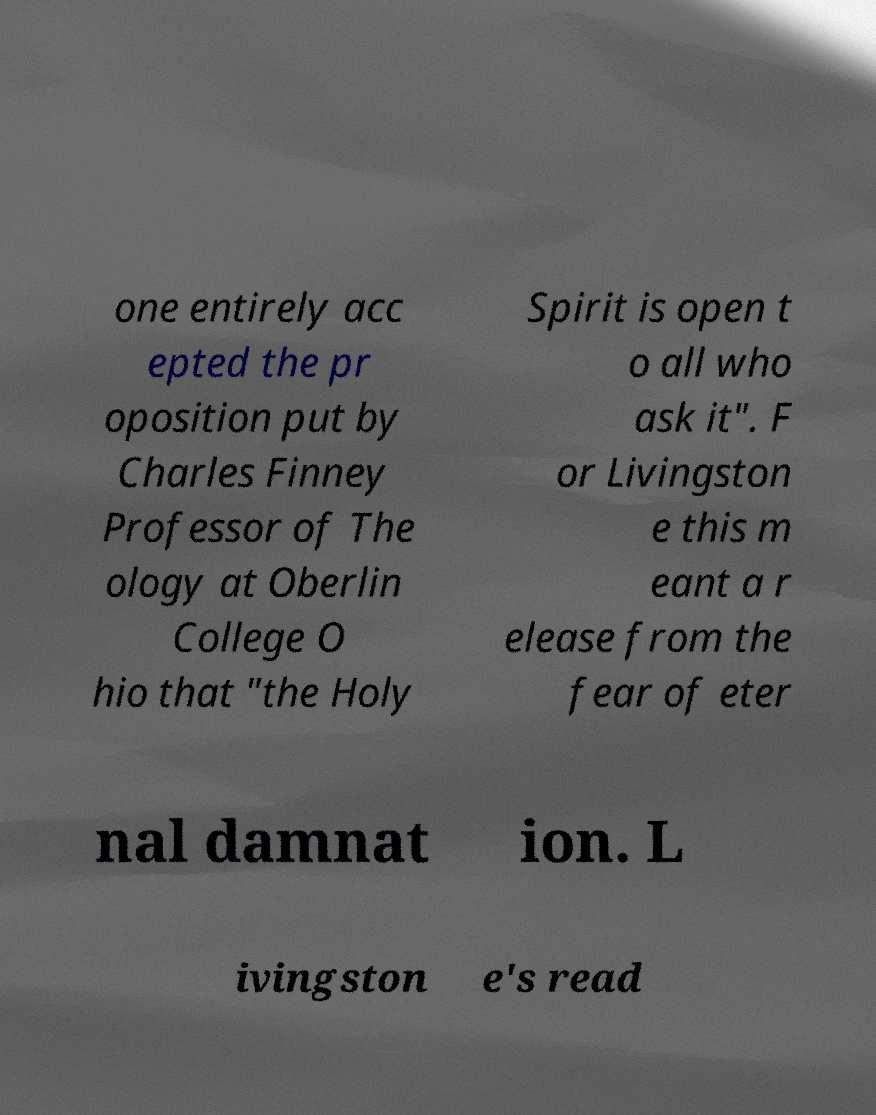I need the written content from this picture converted into text. Can you do that? one entirely acc epted the pr oposition put by Charles Finney Professor of The ology at Oberlin College O hio that "the Holy Spirit is open t o all who ask it". F or Livingston e this m eant a r elease from the fear of eter nal damnat ion. L ivingston e's read 